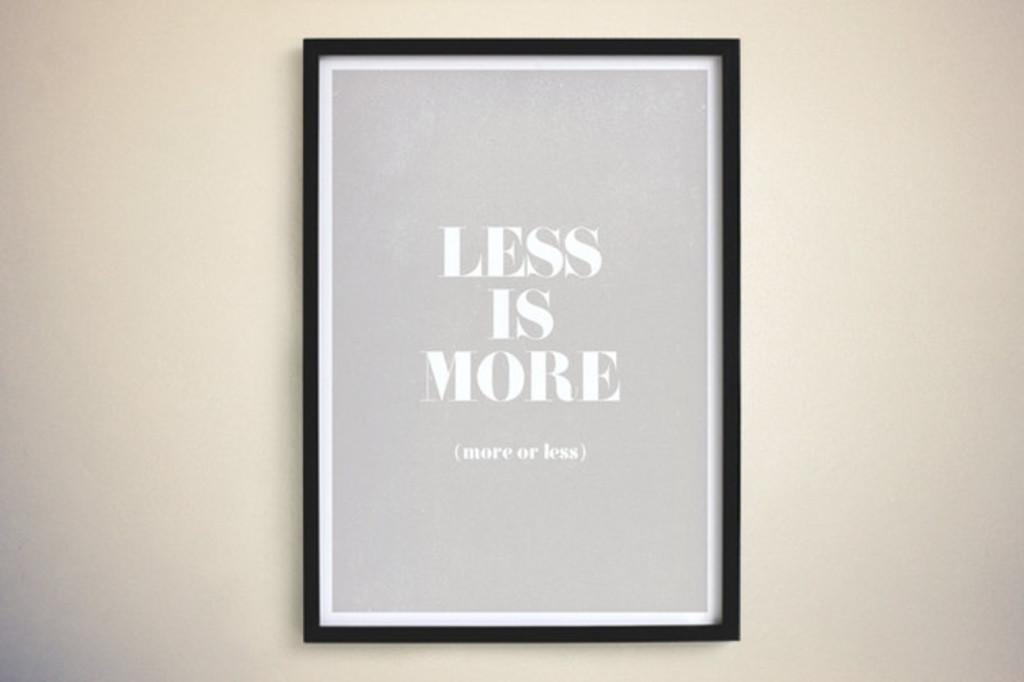<image>
Offer a succinct explanation of the picture presented. Framed artwork that states less is more more or less. 